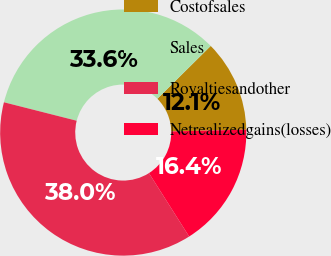Convert chart. <chart><loc_0><loc_0><loc_500><loc_500><pie_chart><fcel>Costofsales<fcel>Sales<fcel>Royaltiesandother<fcel>Netrealizedgains(losses)<nl><fcel>12.05%<fcel>33.62%<fcel>37.95%<fcel>16.38%<nl></chart> 